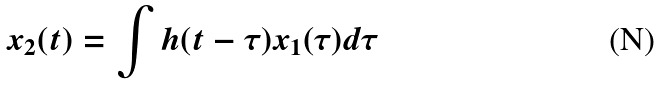Convert formula to latex. <formula><loc_0><loc_0><loc_500><loc_500>x _ { 2 } ( t ) = \int h ( t - \tau ) x _ { 1 } ( \tau ) d \tau</formula> 